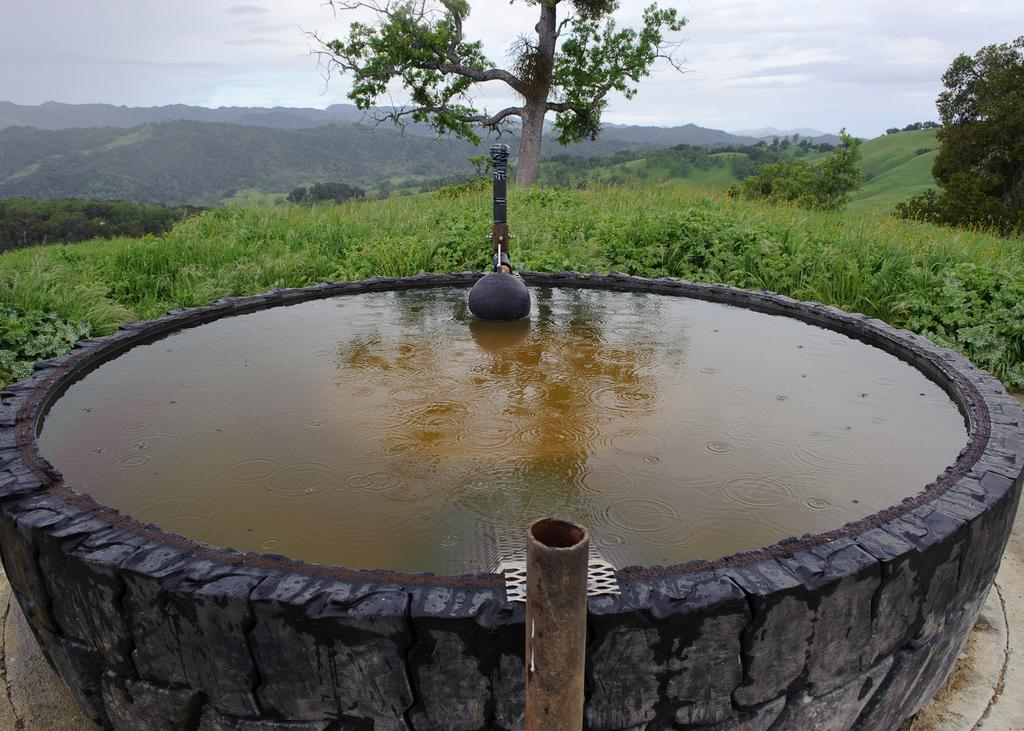What is the main feature of the image? There is water in a pool in the image. What is present on the ground in front of the pool? There is grass on the surface in front of the pool. What can be seen in the distance behind the pool? There are trees and mountains in the background of the image, along with the sky visible in the background. The image shows trees and mountains in the background, and the sky is visible as well. What time of day is the creator of the image depicted in the image? The image does not depict the creator of the image, so it is not possible to determine the time of day they might be depicted in. 